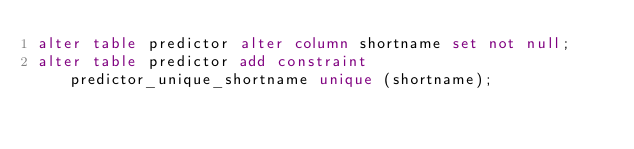<code> <loc_0><loc_0><loc_500><loc_500><_SQL_>alter table predictor alter column shortname set not null;
alter table predictor add constraint predictor_unique_shortname unique (shortname);</code> 